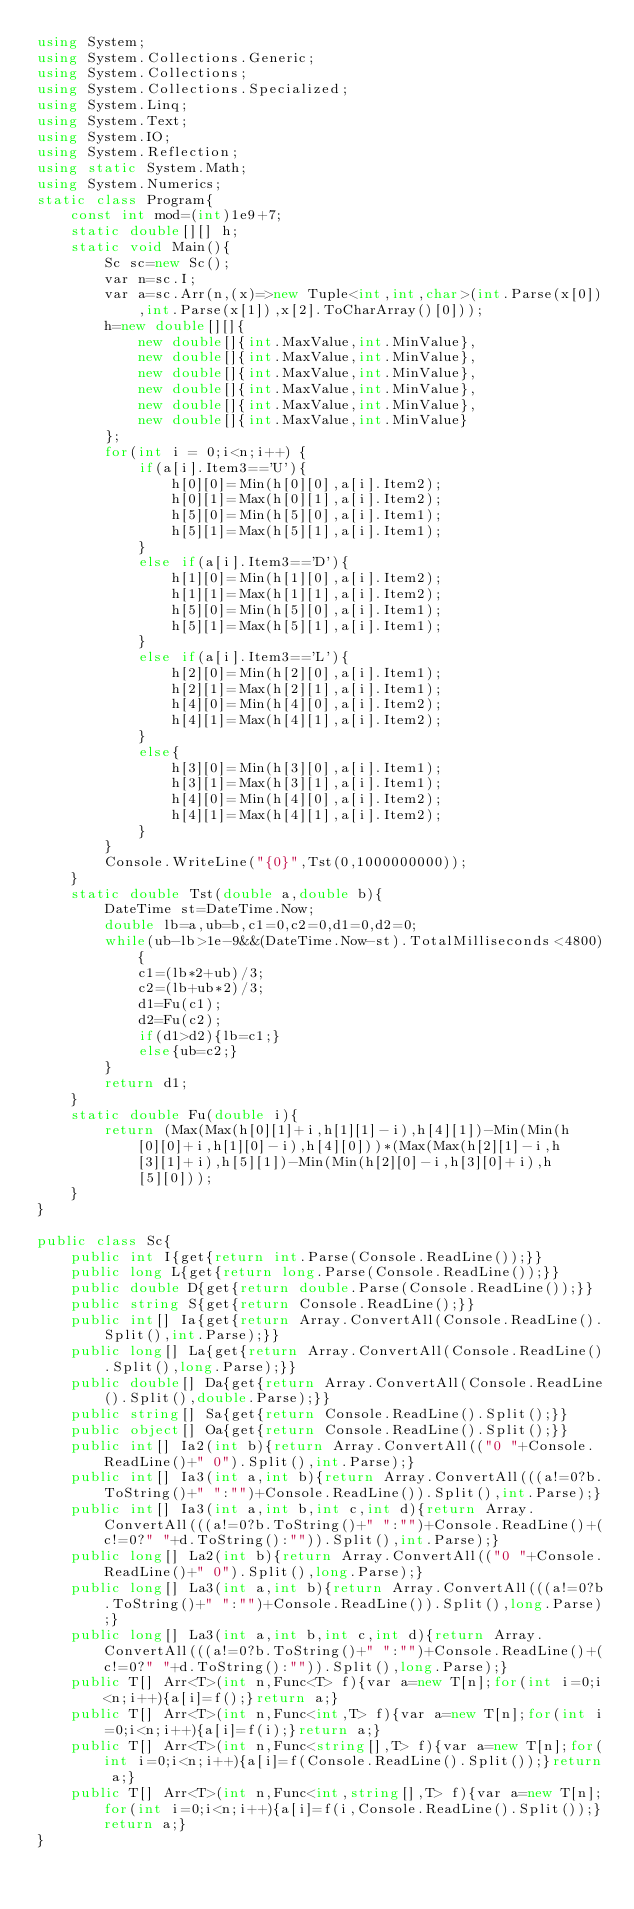Convert code to text. <code><loc_0><loc_0><loc_500><loc_500><_C#_>using System;
using System.Collections.Generic;
using System.Collections;
using System.Collections.Specialized;
using System.Linq;
using System.Text;
using System.IO;
using System.Reflection;
using static System.Math;
using System.Numerics;
static class Program{
	const int mod=(int)1e9+7;
	static double[][] h;
	static void Main(){
		Sc sc=new Sc();
		var n=sc.I;
		var a=sc.Arr(n,(x)=>new Tuple<int,int,char>(int.Parse(x[0]),int.Parse(x[1]),x[2].ToCharArray()[0]));
		h=new double[][]{
			new double[]{int.MaxValue,int.MinValue},
			new double[]{int.MaxValue,int.MinValue},
			new double[]{int.MaxValue,int.MinValue},
			new double[]{int.MaxValue,int.MinValue},
			new double[]{int.MaxValue,int.MinValue},
			new double[]{int.MaxValue,int.MinValue}
		};
		for(int i = 0;i<n;i++) {
			if(a[i].Item3=='U'){
				h[0][0]=Min(h[0][0],a[i].Item2);
				h[0][1]=Max(h[0][1],a[i].Item2);
				h[5][0]=Min(h[5][0],a[i].Item1);
				h[5][1]=Max(h[5][1],a[i].Item1);
			}
			else if(a[i].Item3=='D'){
				h[1][0]=Min(h[1][0],a[i].Item2);
				h[1][1]=Max(h[1][1],a[i].Item2);
				h[5][0]=Min(h[5][0],a[i].Item1);
				h[5][1]=Max(h[5][1],a[i].Item1);
			}
			else if(a[i].Item3=='L'){
				h[2][0]=Min(h[2][0],a[i].Item1);
				h[2][1]=Max(h[2][1],a[i].Item1);
				h[4][0]=Min(h[4][0],a[i].Item2);
				h[4][1]=Max(h[4][1],a[i].Item2);
			}
			else{
				h[3][0]=Min(h[3][0],a[i].Item1);
				h[3][1]=Max(h[3][1],a[i].Item1);
				h[4][0]=Min(h[4][0],a[i].Item2);
				h[4][1]=Max(h[4][1],a[i].Item2);
			}
		}
		Console.WriteLine("{0}",Tst(0,1000000000));
	}
	static double Tst(double a,double b){
		DateTime st=DateTime.Now;
		double lb=a,ub=b,c1=0,c2=0,d1=0,d2=0;
		while(ub-lb>1e-9&&(DateTime.Now-st).TotalMilliseconds<4800){
			c1=(lb*2+ub)/3;
			c2=(lb+ub*2)/3;
			d1=Fu(c1);
			d2=Fu(c2);
			if(d1>d2){lb=c1;}
			else{ub=c2;}
		}
		return d1;
	}
	static double Fu(double i){
		return (Max(Max(h[0][1]+i,h[1][1]-i),h[4][1])-Min(Min(h[0][0]+i,h[1][0]-i),h[4][0]))*(Max(Max(h[2][1]-i,h[3][1]+i),h[5][1])-Min(Min(h[2][0]-i,h[3][0]+i),h[5][0]));
	}
}

public class Sc{
	public int I{get{return int.Parse(Console.ReadLine());}}
	public long L{get{return long.Parse(Console.ReadLine());}}
	public double D{get{return double.Parse(Console.ReadLine());}}
	public string S{get{return Console.ReadLine();}}
	public int[] Ia{get{return Array.ConvertAll(Console.ReadLine().Split(),int.Parse);}}
	public long[] La{get{return Array.ConvertAll(Console.ReadLine().Split(),long.Parse);}}
	public double[] Da{get{return Array.ConvertAll(Console.ReadLine().Split(),double.Parse);}}
	public string[] Sa{get{return Console.ReadLine().Split();}}
	public object[] Oa{get{return Console.ReadLine().Split();}}
	public int[] Ia2(int b){return Array.ConvertAll(("0 "+Console.ReadLine()+" 0").Split(),int.Parse);}
	public int[] Ia3(int a,int b){return Array.ConvertAll(((a!=0?b.ToString()+" ":"")+Console.ReadLine()).Split(),int.Parse);}
	public int[] Ia3(int a,int b,int c,int d){return Array.ConvertAll(((a!=0?b.ToString()+" ":"")+Console.ReadLine()+(c!=0?" "+d.ToString():"")).Split(),int.Parse);}
	public long[] La2(int b){return Array.ConvertAll(("0 "+Console.ReadLine()+" 0").Split(),long.Parse);}
	public long[] La3(int a,int b){return Array.ConvertAll(((a!=0?b.ToString()+" ":"")+Console.ReadLine()).Split(),long.Parse);}
	public long[] La3(int a,int b,int c,int d){return Array.ConvertAll(((a!=0?b.ToString()+" ":"")+Console.ReadLine()+(c!=0?" "+d.ToString():"")).Split(),long.Parse);}
	public T[] Arr<T>(int n,Func<T> f){var a=new T[n];for(int i=0;i<n;i++){a[i]=f();}return a;}
	public T[] Arr<T>(int n,Func<int,T> f){var a=new T[n];for(int i=0;i<n;i++){a[i]=f(i);}return a;}
	public T[] Arr<T>(int n,Func<string[],T> f){var a=new T[n];for(int i=0;i<n;i++){a[i]=f(Console.ReadLine().Split());}return a;}
	public T[] Arr<T>(int n,Func<int,string[],T> f){var a=new T[n];for(int i=0;i<n;i++){a[i]=f(i,Console.ReadLine().Split());}return a;}
}</code> 